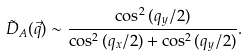Convert formula to latex. <formula><loc_0><loc_0><loc_500><loc_500>\tilde { D } _ { A } ( \vec { q } ) \sim \frac { \cos ^ { 2 } { ( q _ { y } / 2 ) } } { \cos ^ { 2 } { ( q _ { x } / 2 ) } + \cos ^ { 2 } { ( q _ { y } / 2 ) } } .</formula> 